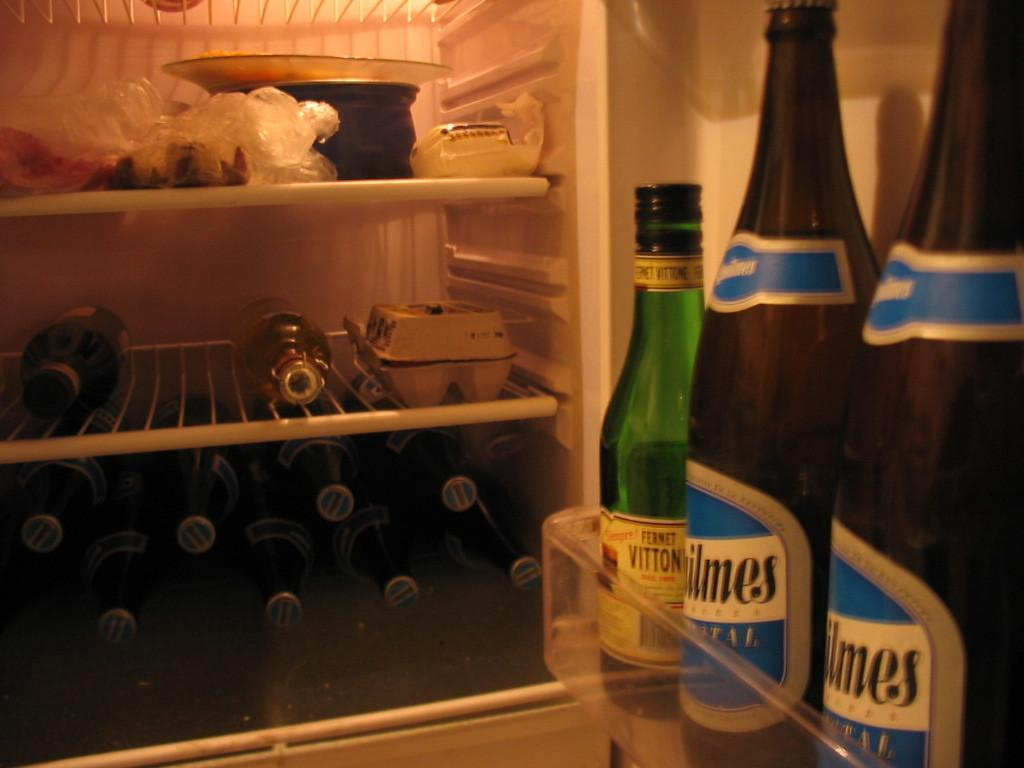What type of appliance is shown in the image? The image shows an inside view of a fridge. What items can be seen inside the fridge? Bottles, bowls, and an egg tray are present in the fridge. What is the location of the fridge in the image? The image is taken inside a room. What type of joke is being told by the mom in the image? There is no mom or joke present in the image; it shows an inside view of a fridge. 